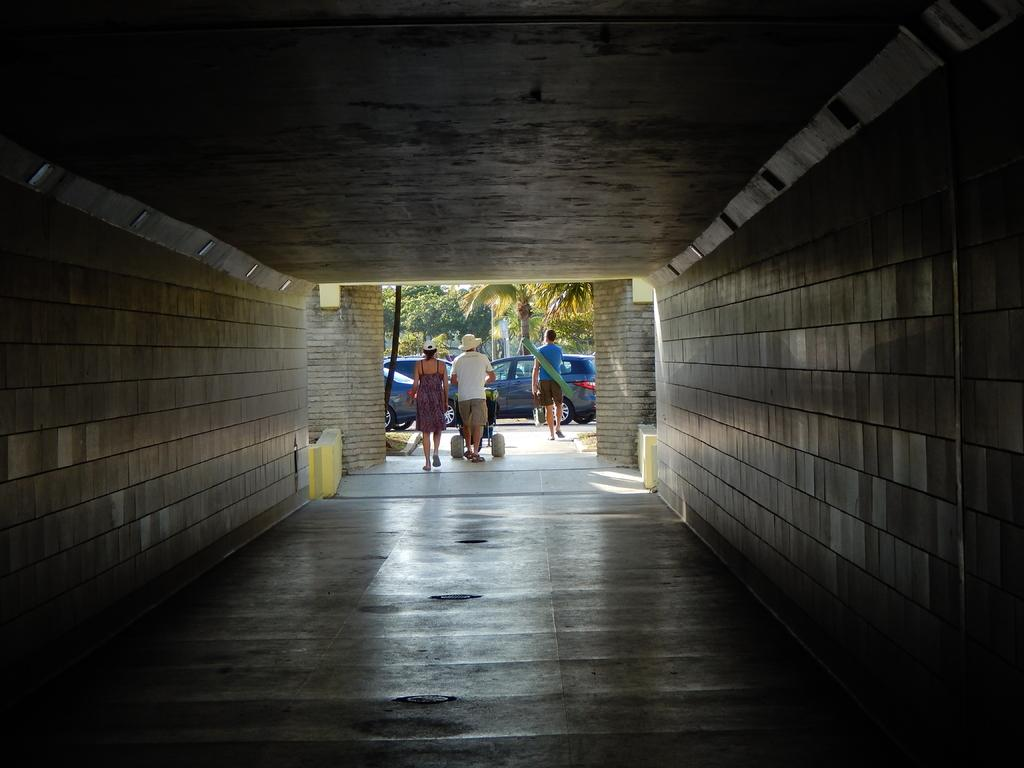What mode of transportation is featured in the picture? There is a subway in the picture. How many people can be seen walking in the image? There are three persons walking on the floor. What is one of the persons carrying? One of the persons is carrying a baby stroller. What can be seen in the background of the image? Cars and trees are visible in the background. What type of magic is being performed by the person with the baby stroller in the image? There is no magic or performance taking place in the image; it simply shows three people walking near a subway. How many fingers does the person carrying the baby stroller have in the image? The number of fingers the person has cannot be determined from the image, as it does not show a close-up of their hands. 